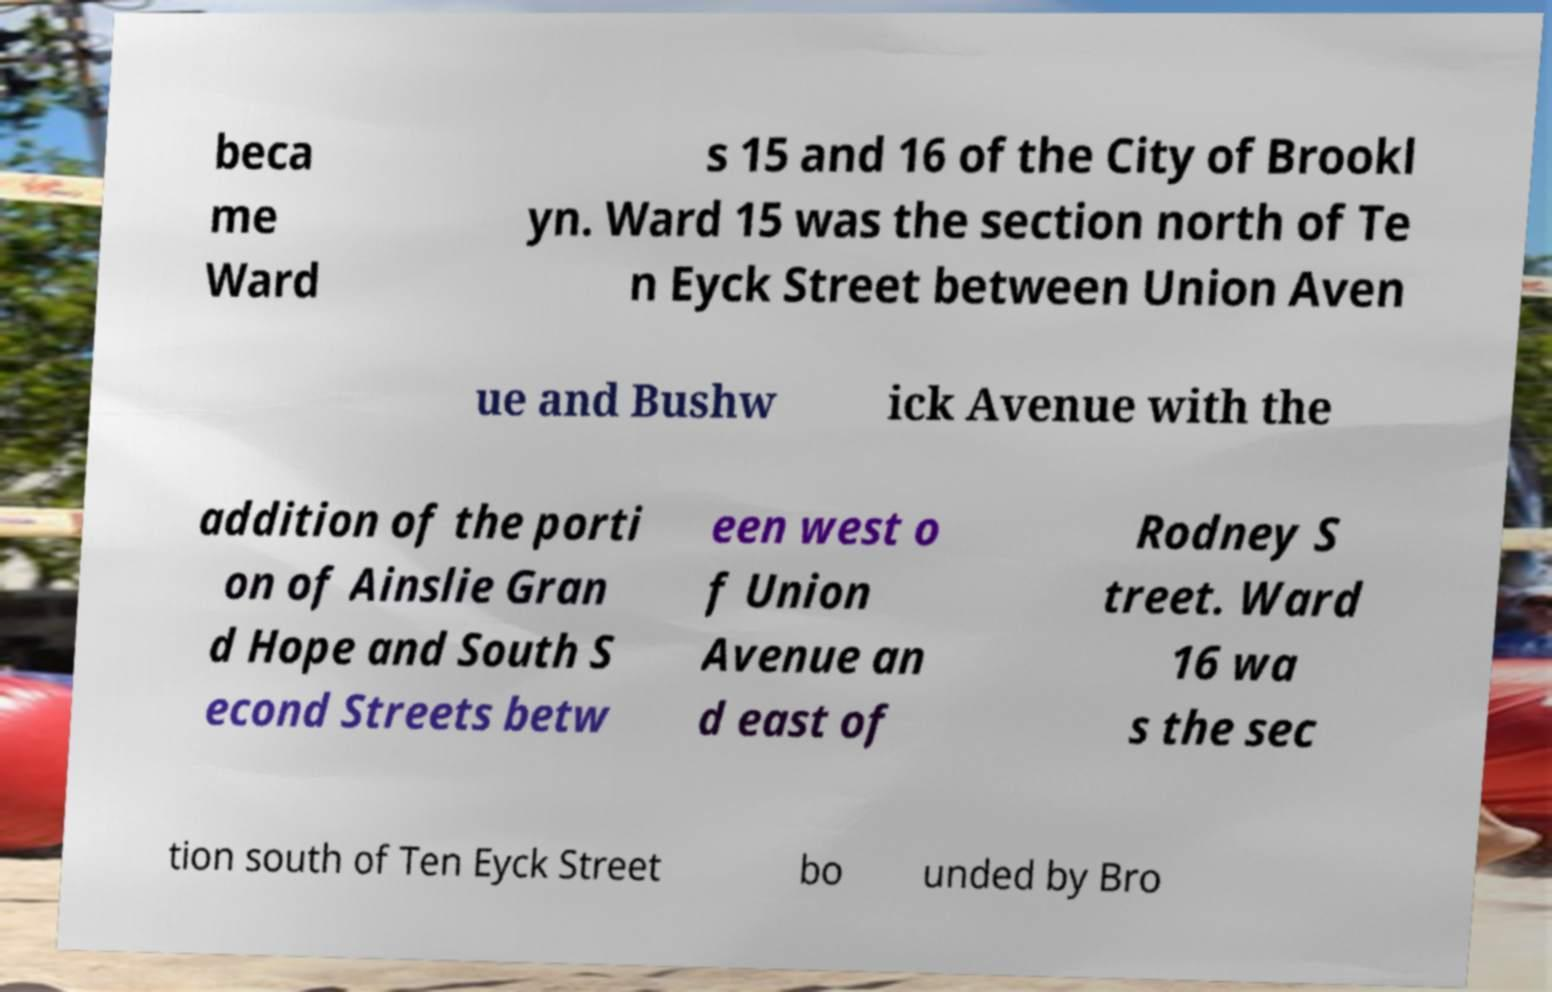Could you extract and type out the text from this image? beca me Ward s 15 and 16 of the City of Brookl yn. Ward 15 was the section north of Te n Eyck Street between Union Aven ue and Bushw ick Avenue with the addition of the porti on of Ainslie Gran d Hope and South S econd Streets betw een west o f Union Avenue an d east of Rodney S treet. Ward 16 wa s the sec tion south of Ten Eyck Street bo unded by Bro 